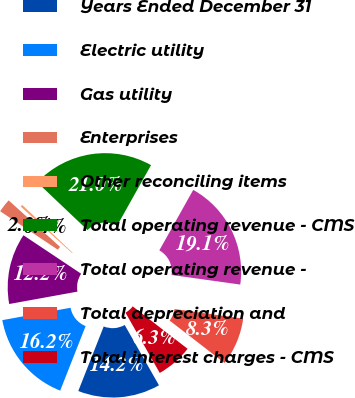Convert chart. <chart><loc_0><loc_0><loc_500><loc_500><pie_chart><fcel>Years Ended December 31<fcel>Electric utility<fcel>Gas utility<fcel>Enterprises<fcel>Other reconciling items<fcel>Total operating revenue - CMS<fcel>Total operating revenue -<fcel>Total depreciation and<fcel>Total interest charges - CMS<nl><fcel>14.2%<fcel>16.17%<fcel>12.22%<fcel>2.35%<fcel>0.38%<fcel>21.04%<fcel>19.07%<fcel>8.27%<fcel>6.3%<nl></chart> 